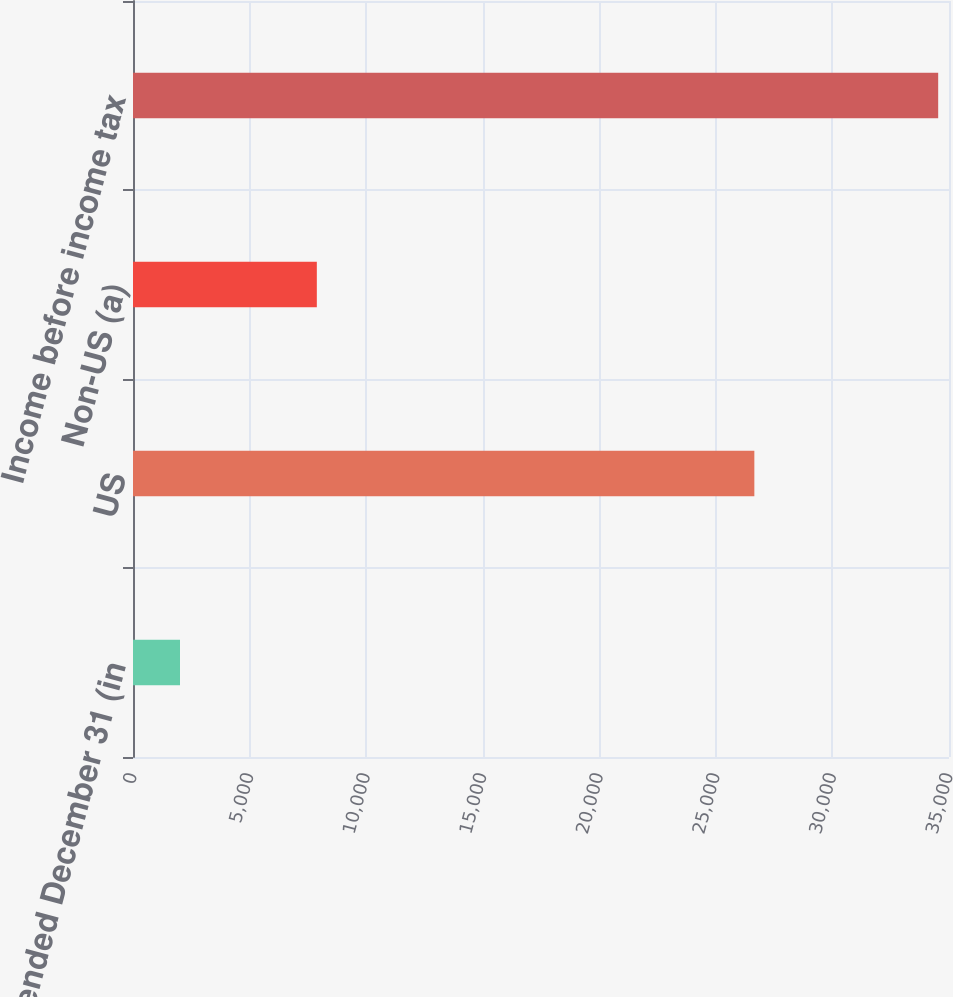<chart> <loc_0><loc_0><loc_500><loc_500><bar_chart><fcel>Year ended December 31 (in<fcel>US<fcel>Non-US (a)<fcel>Income before income tax<nl><fcel>2016<fcel>26651<fcel>7885<fcel>34536<nl></chart> 